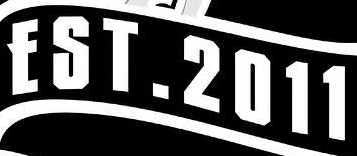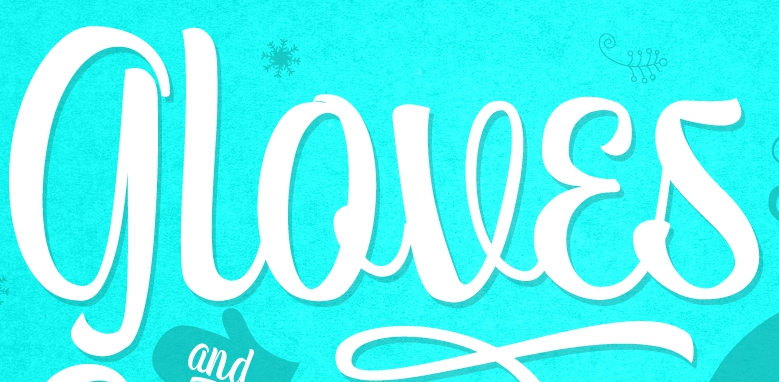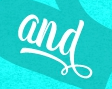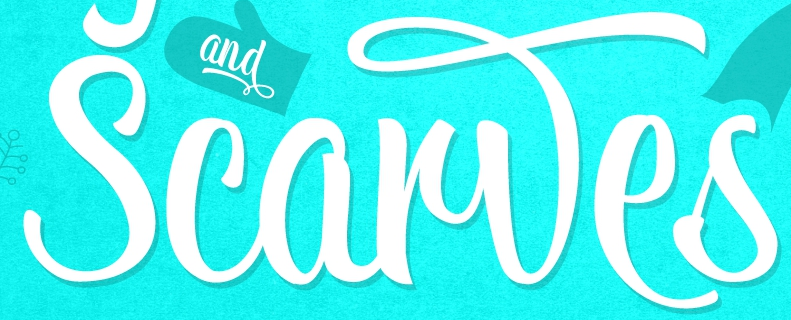What text appears in these images from left to right, separated by a semicolon? EST.2011; gloves; and; Scarwes 